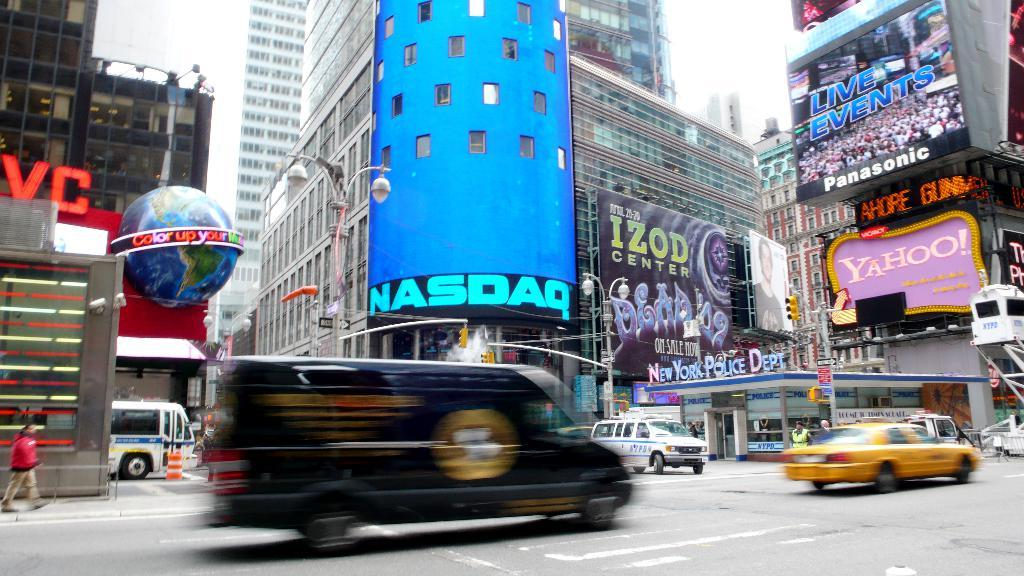<image>
Summarize the visual content of the image. a NASDAQ sign that is on a building 